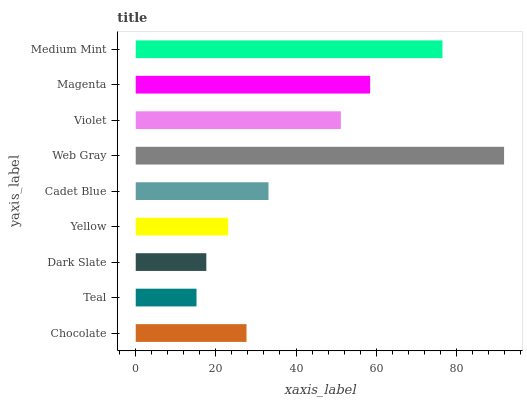Is Teal the minimum?
Answer yes or no. Yes. Is Web Gray the maximum?
Answer yes or no. Yes. Is Dark Slate the minimum?
Answer yes or no. No. Is Dark Slate the maximum?
Answer yes or no. No. Is Dark Slate greater than Teal?
Answer yes or no. Yes. Is Teal less than Dark Slate?
Answer yes or no. Yes. Is Teal greater than Dark Slate?
Answer yes or no. No. Is Dark Slate less than Teal?
Answer yes or no. No. Is Cadet Blue the high median?
Answer yes or no. Yes. Is Cadet Blue the low median?
Answer yes or no. Yes. Is Chocolate the high median?
Answer yes or no. No. Is Medium Mint the low median?
Answer yes or no. No. 